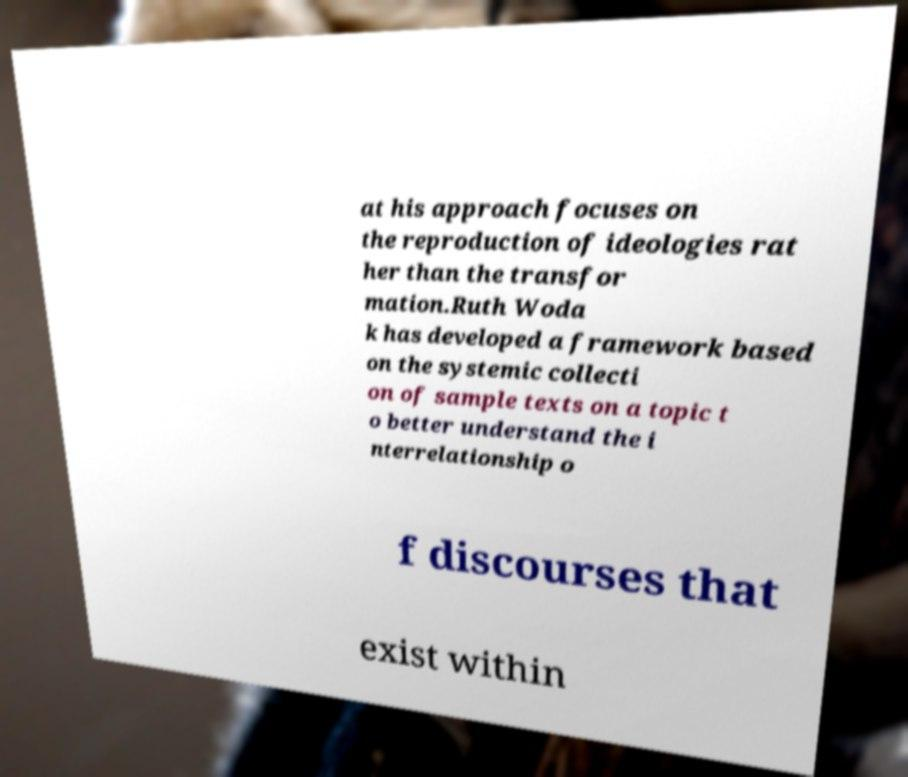Could you assist in decoding the text presented in this image and type it out clearly? at his approach focuses on the reproduction of ideologies rat her than the transfor mation.Ruth Woda k has developed a framework based on the systemic collecti on of sample texts on a topic t o better understand the i nterrelationship o f discourses that exist within 